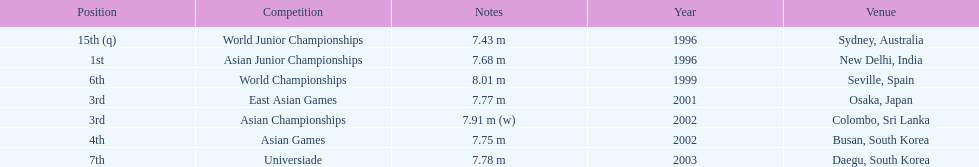In what year was the position of 3rd first achieved? 2001. Could you parse the entire table? {'header': ['Position', 'Competition', 'Notes', 'Year', 'Venue'], 'rows': [['15th (q)', 'World Junior Championships', '7.43 m', '1996', 'Sydney, Australia'], ['1st', 'Asian Junior Championships', '7.68 m', '1996', 'New Delhi, India'], ['6th', 'World Championships', '8.01 m', '1999', 'Seville, Spain'], ['3rd', 'East Asian Games', '7.77 m', '2001', 'Osaka, Japan'], ['3rd', 'Asian Championships', '7.91 m (w)', '2002', 'Colombo, Sri Lanka'], ['4th', 'Asian Games', '7.75 m', '2002', 'Busan, South Korea'], ['7th', 'Universiade', '7.78 m', '2003', 'Daegu, South Korea']]} 